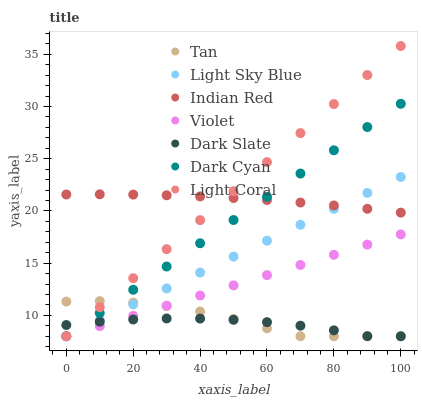Does Dark Slate have the minimum area under the curve?
Answer yes or no. Yes. Does Light Coral have the maximum area under the curve?
Answer yes or no. Yes. Does Light Sky Blue have the minimum area under the curve?
Answer yes or no. No. Does Light Sky Blue have the maximum area under the curve?
Answer yes or no. No. Is Violet the smoothest?
Answer yes or no. Yes. Is Tan the roughest?
Answer yes or no. Yes. Is Dark Slate the smoothest?
Answer yes or no. No. Is Dark Slate the roughest?
Answer yes or no. No. Does Light Coral have the lowest value?
Answer yes or no. Yes. Does Indian Red have the lowest value?
Answer yes or no. No. Does Light Coral have the highest value?
Answer yes or no. Yes. Does Light Sky Blue have the highest value?
Answer yes or no. No. Is Dark Slate less than Indian Red?
Answer yes or no. Yes. Is Indian Red greater than Violet?
Answer yes or no. Yes. Does Light Sky Blue intersect Dark Cyan?
Answer yes or no. Yes. Is Light Sky Blue less than Dark Cyan?
Answer yes or no. No. Is Light Sky Blue greater than Dark Cyan?
Answer yes or no. No. Does Dark Slate intersect Indian Red?
Answer yes or no. No. 